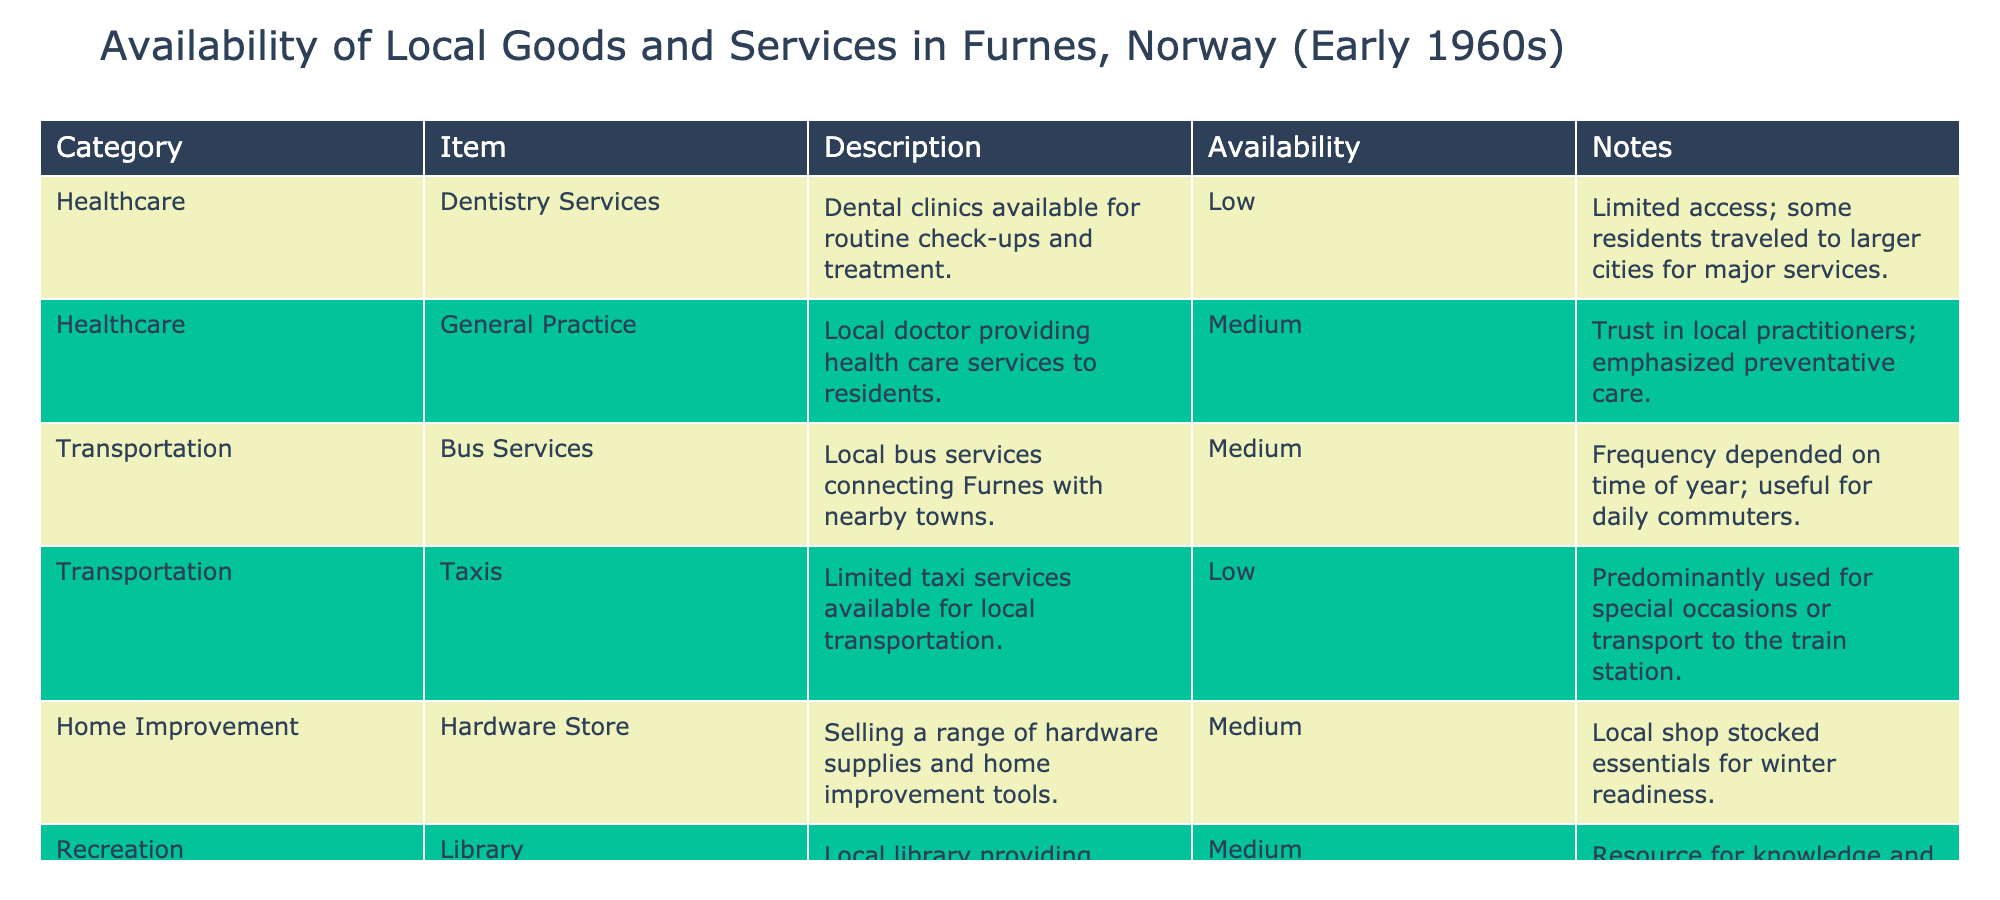What is the availability status of dental services in Furnes? The availability status of dental services is listed as "Low" in the table.
Answer: Low Which item has the highest availability and what is that availability level? The item with the highest availability is the Community Center, which has an availability level of "High."
Answer: High How many services have a medium availability level? There are four services listed with a medium availability level: General Practice, Bus Services, Hardware Store, and Library, making a total of four.
Answer: 4 Is there transportation service available frequently year-round? The table indicates that bus services are of medium availability, but their frequency "depended on the time of year," suggesting that they are not consistently available throughout the year.
Answer: No What is the difference in availability between taxis and the community center? Taxis have low availability while the community center has high availability. The difference in their availability levels is therefore "High - Low," which is a total difference of "High."
Answer: High 